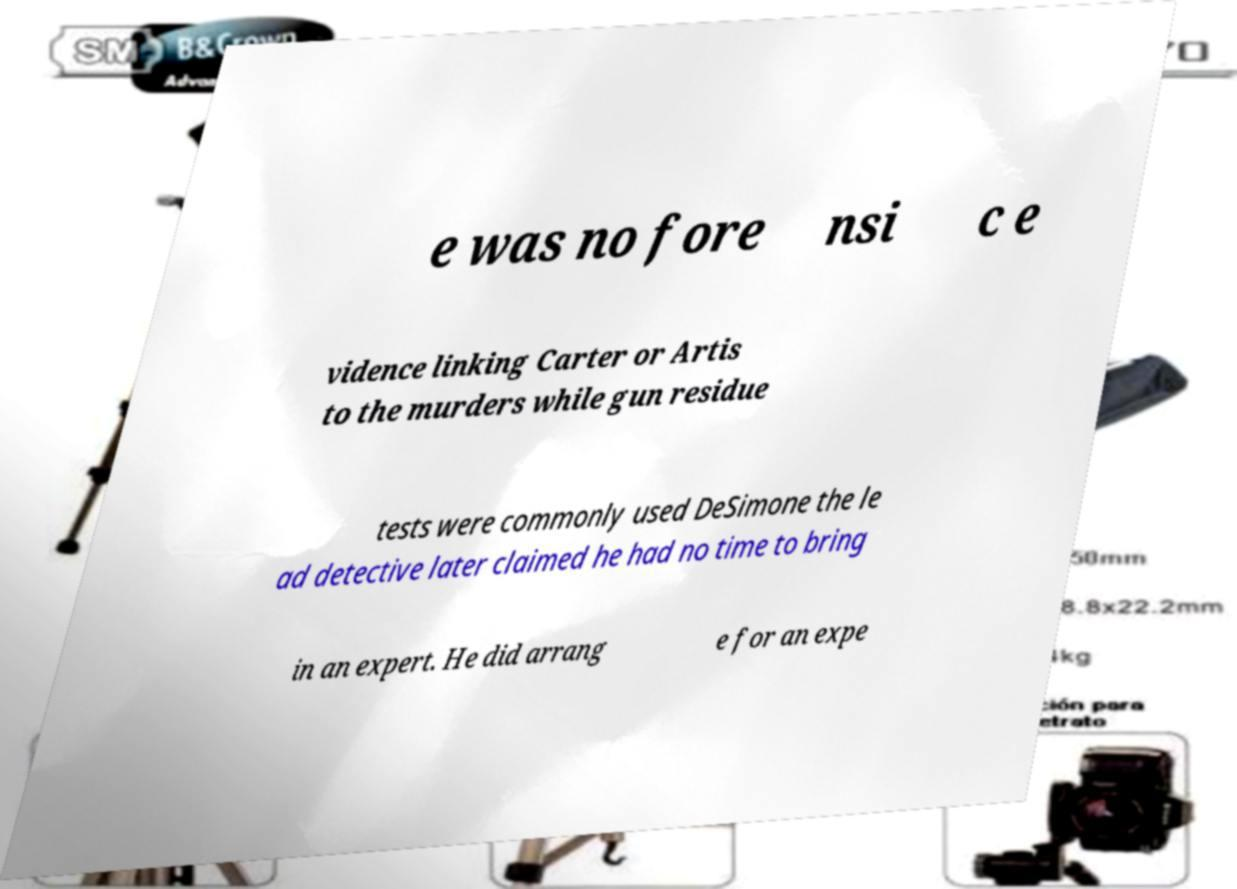For documentation purposes, I need the text within this image transcribed. Could you provide that? e was no fore nsi c e vidence linking Carter or Artis to the murders while gun residue tests were commonly used DeSimone the le ad detective later claimed he had no time to bring in an expert. He did arrang e for an expe 